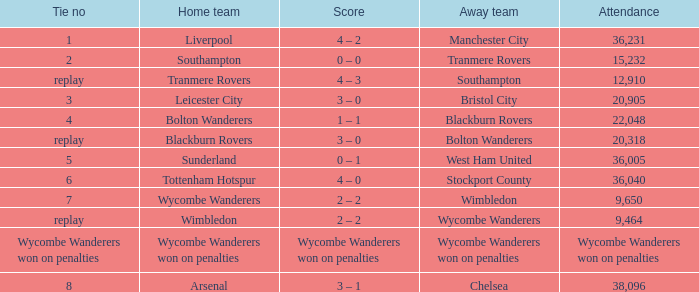What was the score of having a tie of 1? 4 – 2. 